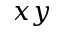<formula> <loc_0><loc_0><loc_500><loc_500>x y</formula> 